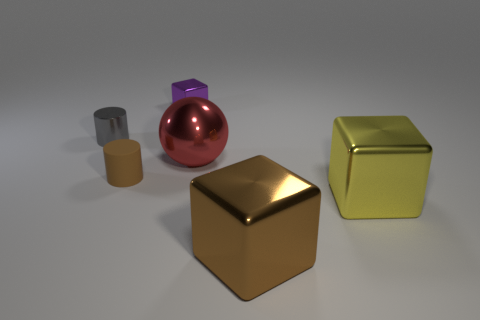Add 4 large metal objects. How many objects exist? 10 Subtract all cylinders. How many objects are left? 4 Subtract 1 brown cylinders. How many objects are left? 5 Subtract all large cubes. Subtract all brown cylinders. How many objects are left? 3 Add 6 large brown metallic objects. How many large brown metallic objects are left? 7 Add 3 tiny purple objects. How many tiny purple objects exist? 4 